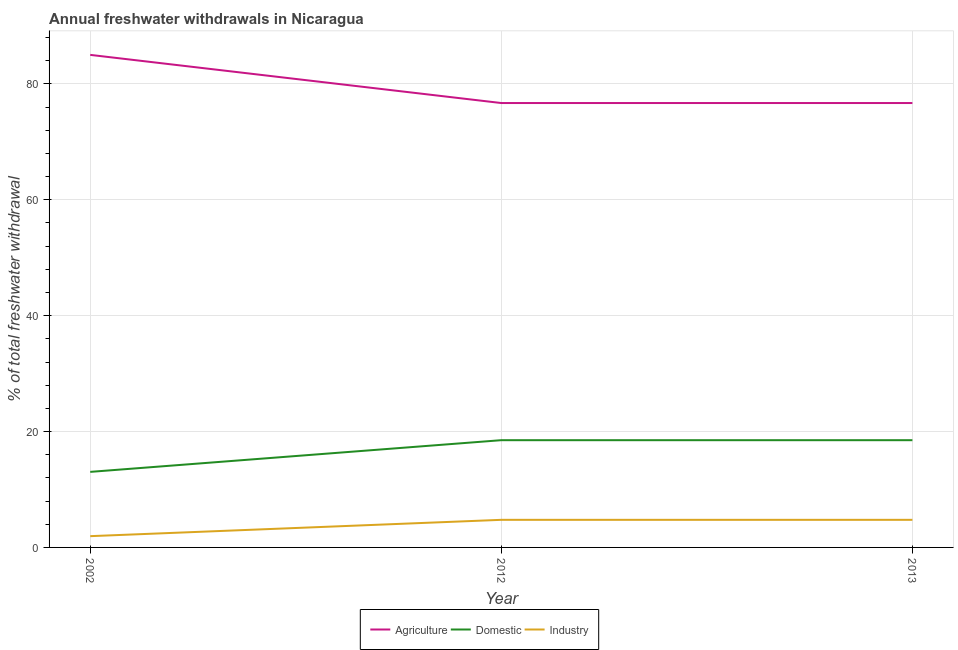How many different coloured lines are there?
Keep it short and to the point. 3. Does the line corresponding to percentage of freshwater withdrawal for agriculture intersect with the line corresponding to percentage of freshwater withdrawal for domestic purposes?
Ensure brevity in your answer.  No. Is the number of lines equal to the number of legend labels?
Offer a very short reply. Yes. What is the percentage of freshwater withdrawal for industry in 2012?
Give a very brief answer. 4.76. Across all years, what is the maximum percentage of freshwater withdrawal for industry?
Offer a very short reply. 4.76. Across all years, what is the minimum percentage of freshwater withdrawal for agriculture?
Give a very brief answer. 76.7. In which year was the percentage of freshwater withdrawal for industry maximum?
Ensure brevity in your answer.  2012. What is the total percentage of freshwater withdrawal for agriculture in the graph?
Keep it short and to the point. 238.41. What is the difference between the percentage of freshwater withdrawal for industry in 2012 and the percentage of freshwater withdrawal for agriculture in 2002?
Provide a succinct answer. -80.25. What is the average percentage of freshwater withdrawal for industry per year?
Keep it short and to the point. 3.82. In the year 2012, what is the difference between the percentage of freshwater withdrawal for industry and percentage of freshwater withdrawal for agriculture?
Provide a short and direct response. -71.94. What is the ratio of the percentage of freshwater withdrawal for agriculture in 2002 to that in 2012?
Keep it short and to the point. 1.11. Is the difference between the percentage of freshwater withdrawal for domestic purposes in 2002 and 2013 greater than the difference between the percentage of freshwater withdrawal for agriculture in 2002 and 2013?
Offer a very short reply. No. What is the difference between the highest and the second highest percentage of freshwater withdrawal for agriculture?
Keep it short and to the point. 8.31. What is the difference between the highest and the lowest percentage of freshwater withdrawal for industry?
Ensure brevity in your answer.  2.82. In how many years, is the percentage of freshwater withdrawal for industry greater than the average percentage of freshwater withdrawal for industry taken over all years?
Keep it short and to the point. 2. Does the percentage of freshwater withdrawal for domestic purposes monotonically increase over the years?
Give a very brief answer. No. How many lines are there?
Make the answer very short. 3. How many years are there in the graph?
Provide a succinct answer. 3. What is the difference between two consecutive major ticks on the Y-axis?
Your response must be concise. 20. Does the graph contain any zero values?
Provide a succinct answer. No. Does the graph contain grids?
Give a very brief answer. Yes. Where does the legend appear in the graph?
Make the answer very short. Bottom center. What is the title of the graph?
Offer a very short reply. Annual freshwater withdrawals in Nicaragua. What is the label or title of the X-axis?
Ensure brevity in your answer.  Year. What is the label or title of the Y-axis?
Make the answer very short. % of total freshwater withdrawal. What is the % of total freshwater withdrawal in Agriculture in 2002?
Provide a succinct answer. 85.01. What is the % of total freshwater withdrawal of Domestic in 2002?
Provide a succinct answer. 13.04. What is the % of total freshwater withdrawal of Industry in 2002?
Give a very brief answer. 1.95. What is the % of total freshwater withdrawal in Agriculture in 2012?
Give a very brief answer. 76.7. What is the % of total freshwater withdrawal in Domestic in 2012?
Give a very brief answer. 18.51. What is the % of total freshwater withdrawal in Industry in 2012?
Make the answer very short. 4.76. What is the % of total freshwater withdrawal of Agriculture in 2013?
Ensure brevity in your answer.  76.7. What is the % of total freshwater withdrawal of Domestic in 2013?
Provide a short and direct response. 18.51. What is the % of total freshwater withdrawal of Industry in 2013?
Offer a terse response. 4.76. Across all years, what is the maximum % of total freshwater withdrawal in Agriculture?
Keep it short and to the point. 85.01. Across all years, what is the maximum % of total freshwater withdrawal in Domestic?
Offer a very short reply. 18.51. Across all years, what is the maximum % of total freshwater withdrawal of Industry?
Your answer should be compact. 4.76. Across all years, what is the minimum % of total freshwater withdrawal of Agriculture?
Keep it short and to the point. 76.7. Across all years, what is the minimum % of total freshwater withdrawal in Domestic?
Your response must be concise. 13.04. Across all years, what is the minimum % of total freshwater withdrawal in Industry?
Ensure brevity in your answer.  1.95. What is the total % of total freshwater withdrawal of Agriculture in the graph?
Ensure brevity in your answer.  238.41. What is the total % of total freshwater withdrawal of Domestic in the graph?
Ensure brevity in your answer.  50.06. What is the total % of total freshwater withdrawal of Industry in the graph?
Your answer should be very brief. 11.47. What is the difference between the % of total freshwater withdrawal of Agriculture in 2002 and that in 2012?
Ensure brevity in your answer.  8.31. What is the difference between the % of total freshwater withdrawal in Domestic in 2002 and that in 2012?
Give a very brief answer. -5.47. What is the difference between the % of total freshwater withdrawal in Industry in 2002 and that in 2012?
Offer a very short reply. -2.82. What is the difference between the % of total freshwater withdrawal of Agriculture in 2002 and that in 2013?
Your answer should be very brief. 8.31. What is the difference between the % of total freshwater withdrawal in Domestic in 2002 and that in 2013?
Provide a succinct answer. -5.47. What is the difference between the % of total freshwater withdrawal in Industry in 2002 and that in 2013?
Provide a succinct answer. -2.82. What is the difference between the % of total freshwater withdrawal in Industry in 2012 and that in 2013?
Provide a short and direct response. 0. What is the difference between the % of total freshwater withdrawal of Agriculture in 2002 and the % of total freshwater withdrawal of Domestic in 2012?
Make the answer very short. 66.5. What is the difference between the % of total freshwater withdrawal of Agriculture in 2002 and the % of total freshwater withdrawal of Industry in 2012?
Give a very brief answer. 80.25. What is the difference between the % of total freshwater withdrawal of Domestic in 2002 and the % of total freshwater withdrawal of Industry in 2012?
Offer a very short reply. 8.28. What is the difference between the % of total freshwater withdrawal of Agriculture in 2002 and the % of total freshwater withdrawal of Domestic in 2013?
Offer a very short reply. 66.5. What is the difference between the % of total freshwater withdrawal of Agriculture in 2002 and the % of total freshwater withdrawal of Industry in 2013?
Make the answer very short. 80.25. What is the difference between the % of total freshwater withdrawal of Domestic in 2002 and the % of total freshwater withdrawal of Industry in 2013?
Provide a short and direct response. 8.28. What is the difference between the % of total freshwater withdrawal of Agriculture in 2012 and the % of total freshwater withdrawal of Domestic in 2013?
Ensure brevity in your answer.  58.19. What is the difference between the % of total freshwater withdrawal of Agriculture in 2012 and the % of total freshwater withdrawal of Industry in 2013?
Make the answer very short. 71.94. What is the difference between the % of total freshwater withdrawal of Domestic in 2012 and the % of total freshwater withdrawal of Industry in 2013?
Your answer should be compact. 13.75. What is the average % of total freshwater withdrawal of Agriculture per year?
Your response must be concise. 79.47. What is the average % of total freshwater withdrawal of Domestic per year?
Make the answer very short. 16.69. What is the average % of total freshwater withdrawal in Industry per year?
Provide a short and direct response. 3.82. In the year 2002, what is the difference between the % of total freshwater withdrawal in Agriculture and % of total freshwater withdrawal in Domestic?
Offer a terse response. 71.97. In the year 2002, what is the difference between the % of total freshwater withdrawal of Agriculture and % of total freshwater withdrawal of Industry?
Keep it short and to the point. 83.06. In the year 2002, what is the difference between the % of total freshwater withdrawal of Domestic and % of total freshwater withdrawal of Industry?
Provide a short and direct response. 11.1. In the year 2012, what is the difference between the % of total freshwater withdrawal of Agriculture and % of total freshwater withdrawal of Domestic?
Ensure brevity in your answer.  58.19. In the year 2012, what is the difference between the % of total freshwater withdrawal of Agriculture and % of total freshwater withdrawal of Industry?
Offer a terse response. 71.94. In the year 2012, what is the difference between the % of total freshwater withdrawal in Domestic and % of total freshwater withdrawal in Industry?
Give a very brief answer. 13.75. In the year 2013, what is the difference between the % of total freshwater withdrawal of Agriculture and % of total freshwater withdrawal of Domestic?
Offer a terse response. 58.19. In the year 2013, what is the difference between the % of total freshwater withdrawal of Agriculture and % of total freshwater withdrawal of Industry?
Provide a short and direct response. 71.94. In the year 2013, what is the difference between the % of total freshwater withdrawal in Domestic and % of total freshwater withdrawal in Industry?
Your response must be concise. 13.75. What is the ratio of the % of total freshwater withdrawal of Agriculture in 2002 to that in 2012?
Offer a very short reply. 1.11. What is the ratio of the % of total freshwater withdrawal of Domestic in 2002 to that in 2012?
Provide a succinct answer. 0.7. What is the ratio of the % of total freshwater withdrawal of Industry in 2002 to that in 2012?
Your response must be concise. 0.41. What is the ratio of the % of total freshwater withdrawal of Agriculture in 2002 to that in 2013?
Provide a succinct answer. 1.11. What is the ratio of the % of total freshwater withdrawal of Domestic in 2002 to that in 2013?
Provide a short and direct response. 0.7. What is the ratio of the % of total freshwater withdrawal of Industry in 2002 to that in 2013?
Your answer should be very brief. 0.41. What is the ratio of the % of total freshwater withdrawal in Agriculture in 2012 to that in 2013?
Your response must be concise. 1. What is the ratio of the % of total freshwater withdrawal in Industry in 2012 to that in 2013?
Offer a terse response. 1. What is the difference between the highest and the second highest % of total freshwater withdrawal in Agriculture?
Your response must be concise. 8.31. What is the difference between the highest and the second highest % of total freshwater withdrawal of Domestic?
Your answer should be compact. 0. What is the difference between the highest and the second highest % of total freshwater withdrawal of Industry?
Your answer should be very brief. 0. What is the difference between the highest and the lowest % of total freshwater withdrawal of Agriculture?
Offer a terse response. 8.31. What is the difference between the highest and the lowest % of total freshwater withdrawal in Domestic?
Keep it short and to the point. 5.47. What is the difference between the highest and the lowest % of total freshwater withdrawal of Industry?
Ensure brevity in your answer.  2.82. 